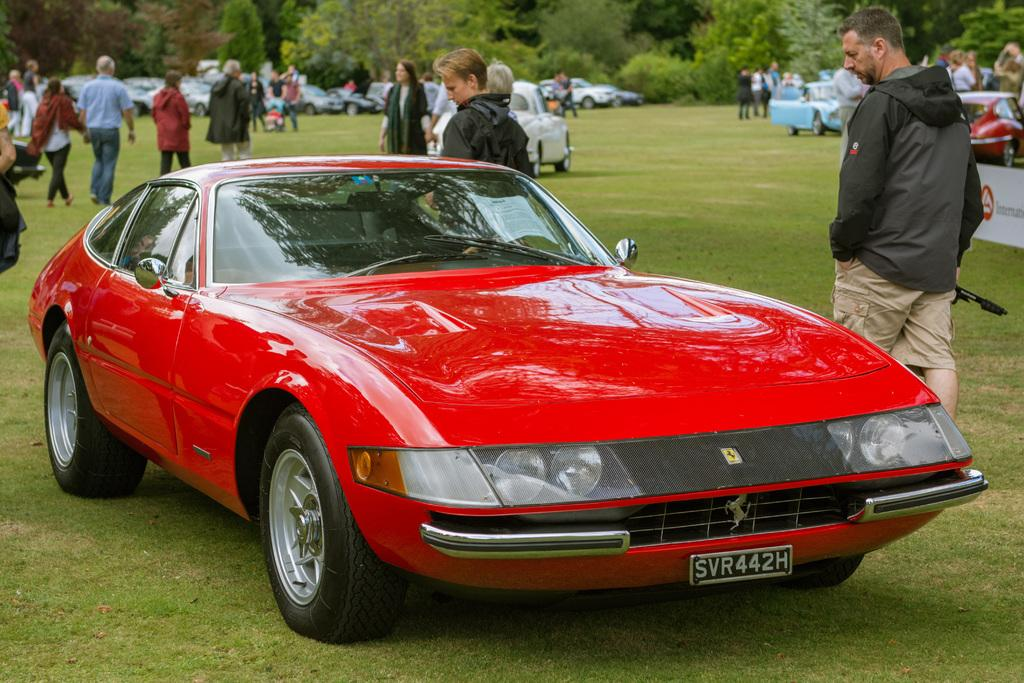What color is the vehicle in the image? The vehicle in the image is red. What can be seen happening in the background of the image? There is a group of people walking in the background. What else is visible in the background of the image? There are other vehicles and trees with green color visible in the background. What type of bubble is being used by the hen in the image? There is no hen or bubble present in the image. 